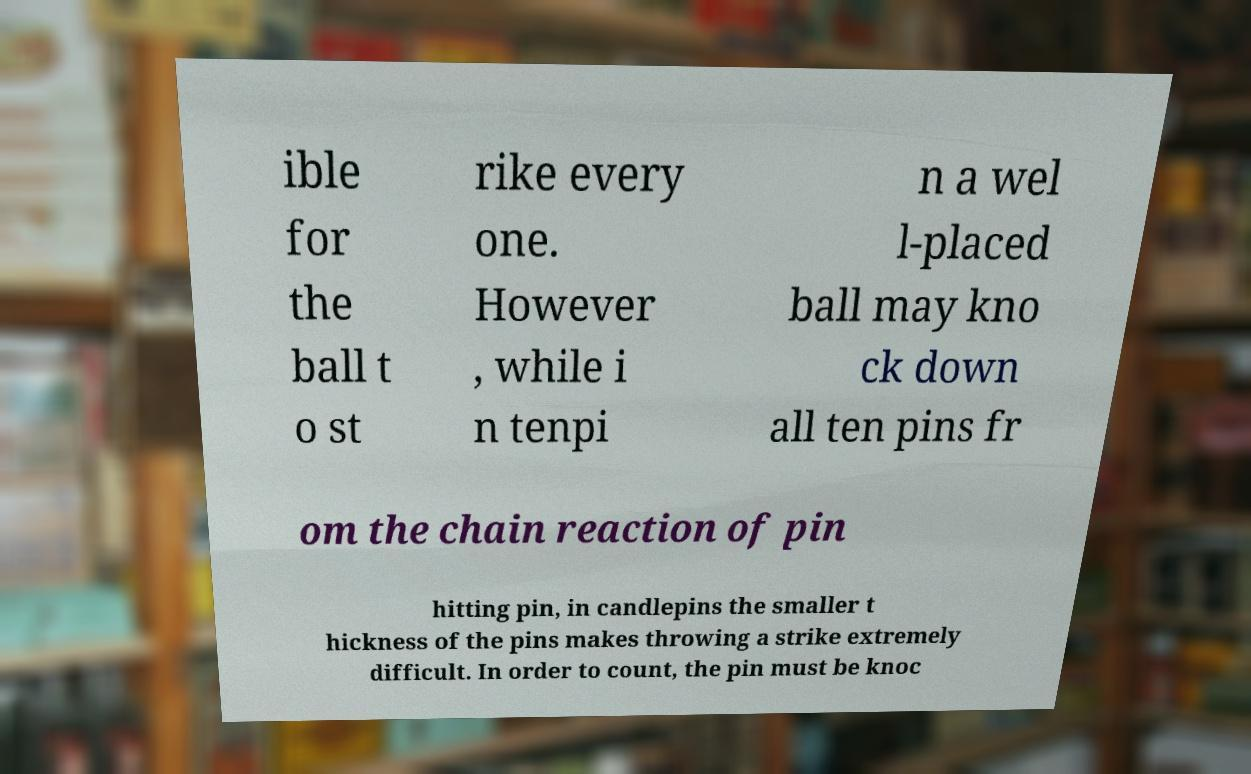What messages or text are displayed in this image? I need them in a readable, typed format. ible for the ball t o st rike every one. However , while i n tenpi n a wel l-placed ball may kno ck down all ten pins fr om the chain reaction of pin hitting pin, in candlepins the smaller t hickness of the pins makes throwing a strike extremely difficult. In order to count, the pin must be knoc 